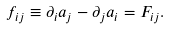Convert formula to latex. <formula><loc_0><loc_0><loc_500><loc_500>f _ { i j } \equiv \partial _ { i } a _ { j } - \partial _ { j } a _ { i } = F _ { i j } .</formula> 